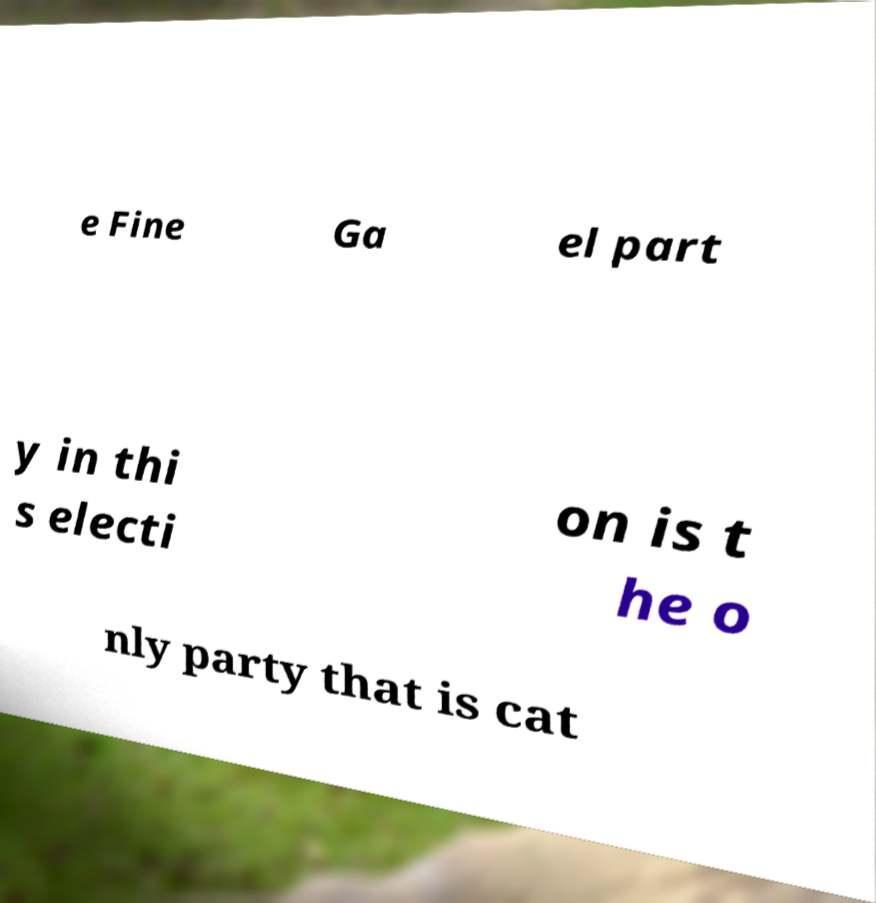Can you read and provide the text displayed in the image?This photo seems to have some interesting text. Can you extract and type it out for me? e Fine Ga el part y in thi s electi on is t he o nly party that is cat 